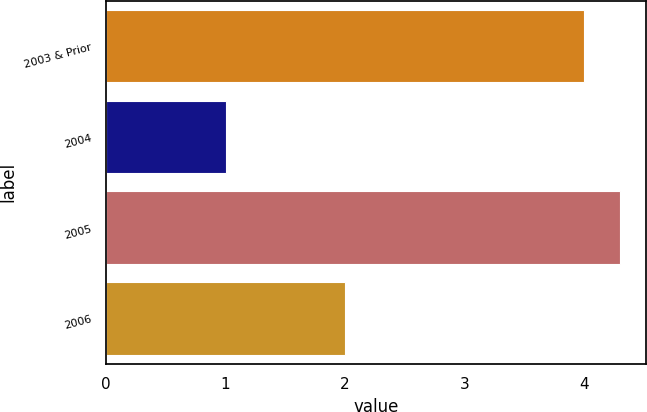Convert chart. <chart><loc_0><loc_0><loc_500><loc_500><bar_chart><fcel>2003 & Prior<fcel>2004<fcel>2005<fcel>2006<nl><fcel>4<fcel>1<fcel>4.3<fcel>2<nl></chart> 